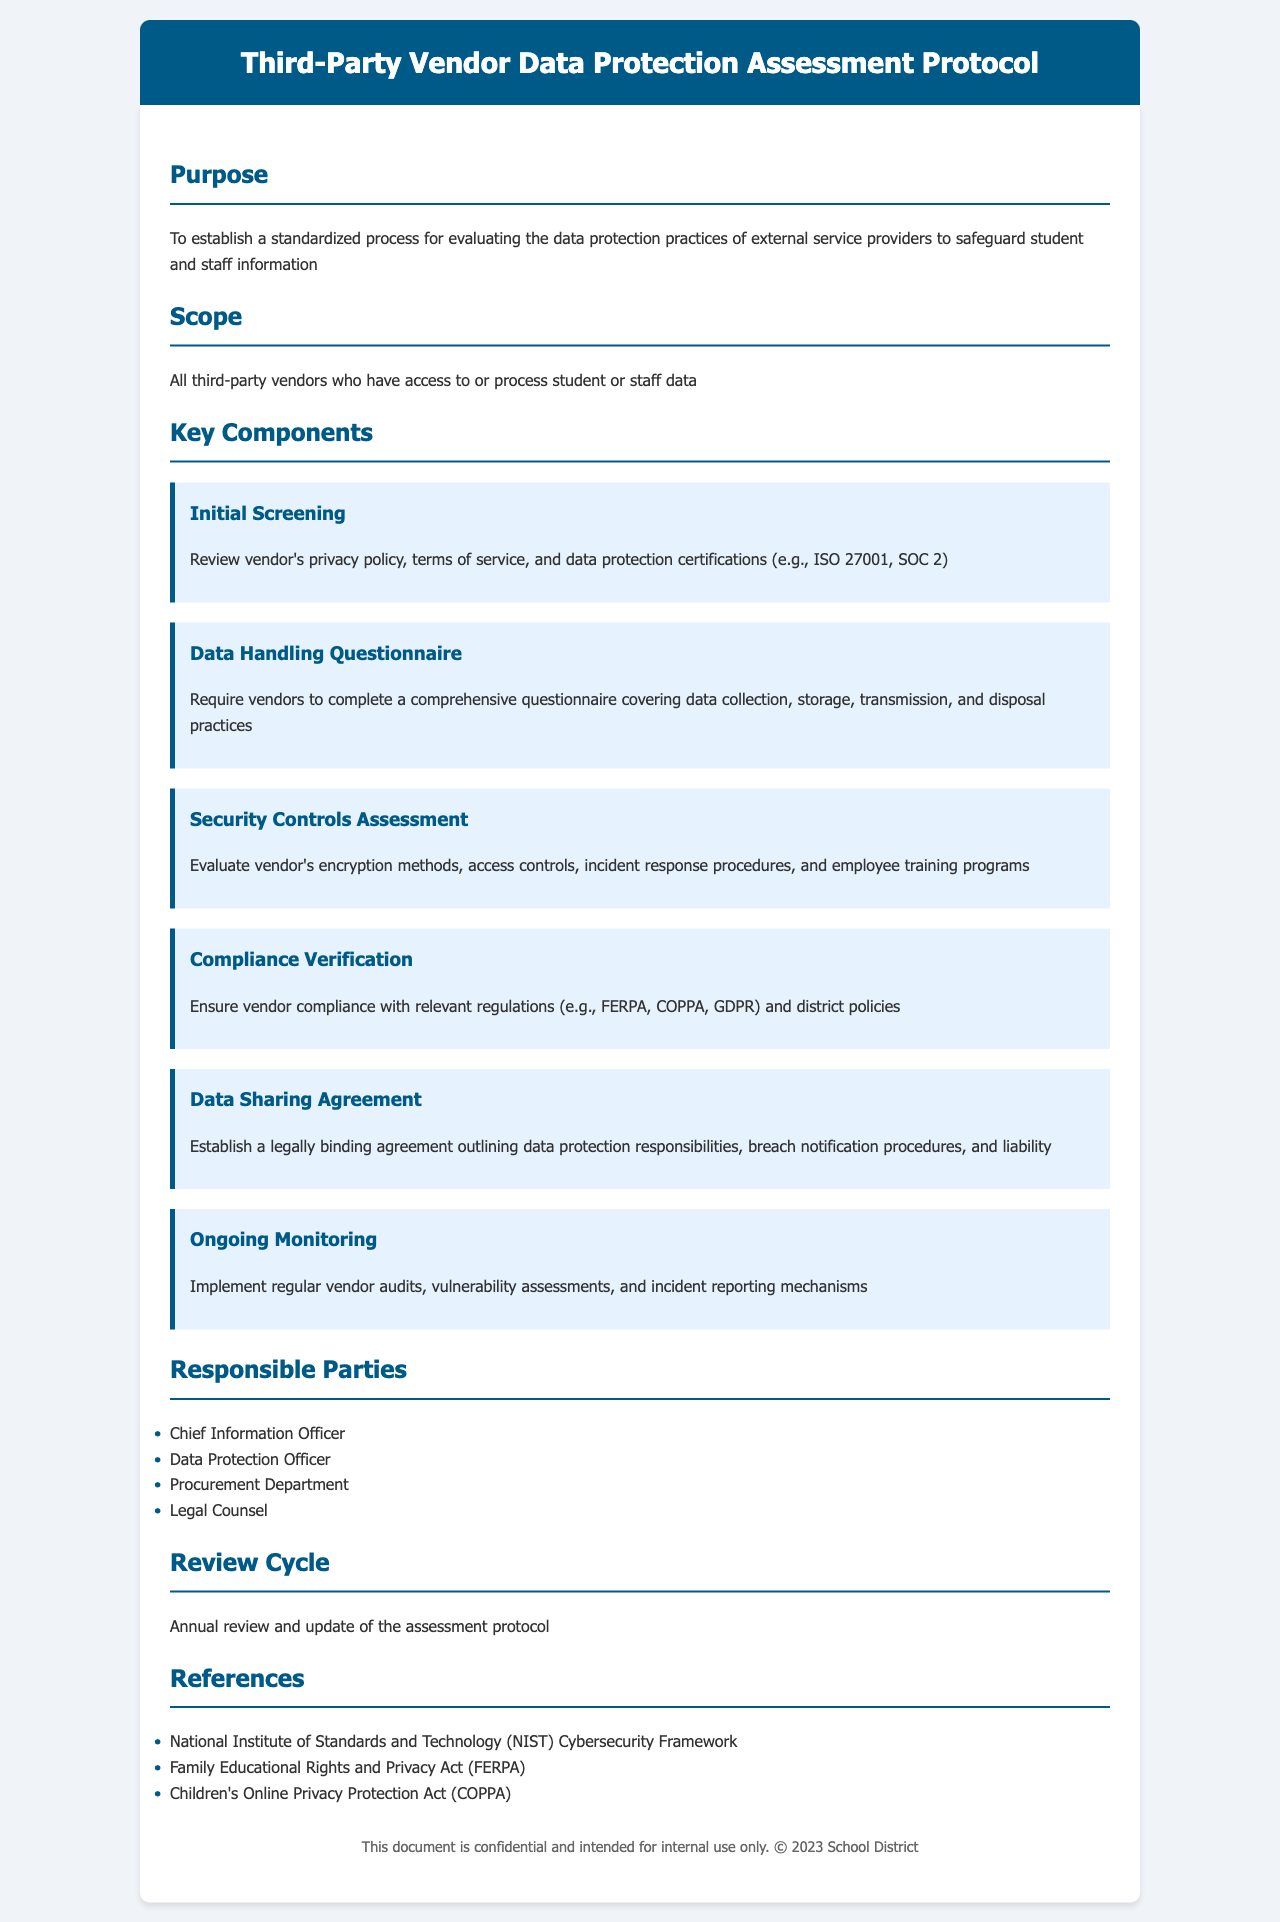What is the purpose of the protocol? The purpose is to establish a standardized process for evaluating the data protection practices of external service providers to safeguard student and staff information.
Answer: To establish a standardized process for evaluating data protection practices What is the scope of the protocol? The scope refers to all third-party vendors who have access to or process student or staff data.
Answer: All third-party vendors who have access to or process student or staff data Name one key component of the assessment. The document outlines several key components, such as Initial Screening, Data Handling Questionnaire, etc.
Answer: Initial Screening Which parties are responsible for the assessment? The responsible parties listed in the document include various roles, including Chief Information Officer and others.
Answer: Chief Information Officer How often will the assessment protocol be reviewed? The review cycle mentions that the protocol will be reviewed annually.
Answer: Annual What regulations should vendors comply with? The document states vendors should comply with relevant regulations including FERPA, COPPA, and GDPR.
Answer: FERPA, COPPA, GDPR What is expected from the data sharing agreement? The data sharing agreement should outline data protection responsibilities and breach notification procedures.
Answer: Data protection responsibilities, breach notification procedures What is required in the Data Handling Questionnaire? The questionnaire requires vendors to cover aspects of data collection, storage, transmission, and disposal practices.
Answer: Data collection, storage, transmission, and disposal practices 